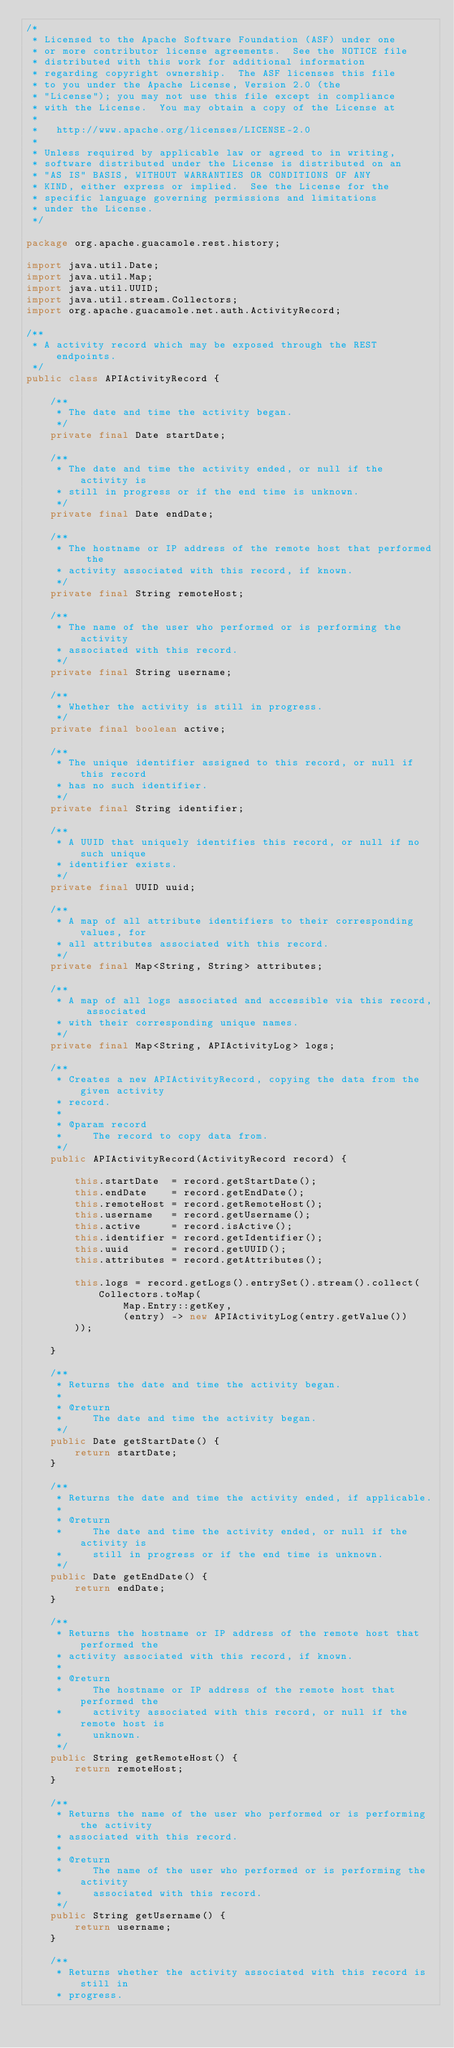Convert code to text. <code><loc_0><loc_0><loc_500><loc_500><_Java_>/*
 * Licensed to the Apache Software Foundation (ASF) under one
 * or more contributor license agreements.  See the NOTICE file
 * distributed with this work for additional information
 * regarding copyright ownership.  The ASF licenses this file
 * to you under the Apache License, Version 2.0 (the
 * "License"); you may not use this file except in compliance
 * with the License.  You may obtain a copy of the License at
 *
 *   http://www.apache.org/licenses/LICENSE-2.0
 *
 * Unless required by applicable law or agreed to in writing,
 * software distributed under the License is distributed on an
 * "AS IS" BASIS, WITHOUT WARRANTIES OR CONDITIONS OF ANY
 * KIND, either express or implied.  See the License for the
 * specific language governing permissions and limitations
 * under the License.
 */

package org.apache.guacamole.rest.history;

import java.util.Date;
import java.util.Map;
import java.util.UUID;
import java.util.stream.Collectors;
import org.apache.guacamole.net.auth.ActivityRecord;

/**
 * A activity record which may be exposed through the REST endpoints.
 */
public class APIActivityRecord {

    /**
     * The date and time the activity began.
     */
    private final Date startDate;

    /**
     * The date and time the activity ended, or null if the activity is
     * still in progress or if the end time is unknown.
     */
    private final Date endDate;

    /**
     * The hostname or IP address of the remote host that performed the
     * activity associated with this record, if known.
     */
    private final String remoteHost;

    /**
     * The name of the user who performed or is performing the activity
     * associated with this record.
     */
    private final String username;

    /**
     * Whether the activity is still in progress.
     */
    private final boolean active;

    /**
     * The unique identifier assigned to this record, or null if this record
     * has no such identifier.
     */
    private final String identifier;
    
    /**
     * A UUID that uniquely identifies this record, or null if no such unique
     * identifier exists.
     */
    private final UUID uuid;

    /**
     * A map of all attribute identifiers to their corresponding values, for
     * all attributes associated with this record.
     */
    private final Map<String, String> attributes;

    /**
     * A map of all logs associated and accessible via this record, associated
     * with their corresponding unique names.
     */
    private final Map<String, APIActivityLog> logs;

    /**
     * Creates a new APIActivityRecord, copying the data from the given activity
     * record.
     *
     * @param record
     *     The record to copy data from.
     */
    public APIActivityRecord(ActivityRecord record) {

        this.startDate  = record.getStartDate();
        this.endDate    = record.getEndDate();
        this.remoteHost = record.getRemoteHost();
        this.username   = record.getUsername();
        this.active     = record.isActive();
        this.identifier = record.getIdentifier();
        this.uuid       = record.getUUID();
        this.attributes = record.getAttributes();

        this.logs = record.getLogs().entrySet().stream().collect(Collectors.toMap(
                Map.Entry::getKey,
                (entry) -> new APIActivityLog(entry.getValue())
        ));

    }

    /**
     * Returns the date and time the activity began.
     *
     * @return
     *     The date and time the activity began.
     */
    public Date getStartDate() {
        return startDate;
    }

    /**
     * Returns the date and time the activity ended, if applicable.
     *
     * @return
     *     The date and time the activity ended, or null if the activity is
     *     still in progress or if the end time is unknown.
     */
    public Date getEndDate() {
        return endDate;
    }

    /**
     * Returns the hostname or IP address of the remote host that performed the
     * activity associated with this record, if known.
     *
     * @return
     *     The hostname or IP address of the remote host that performed the
     *     activity associated with this record, or null if the remote host is
     *     unknown.
     */
    public String getRemoteHost() {
        return remoteHost;
    }

    /**
     * Returns the name of the user who performed or is performing the activity
     * associated with this record.
     *
     * @return
     *     The name of the user who performed or is performing the activity
     *     associated with this record.
     */
    public String getUsername() {
        return username;
    }

    /**
     * Returns whether the activity associated with this record is still in
     * progress.</code> 